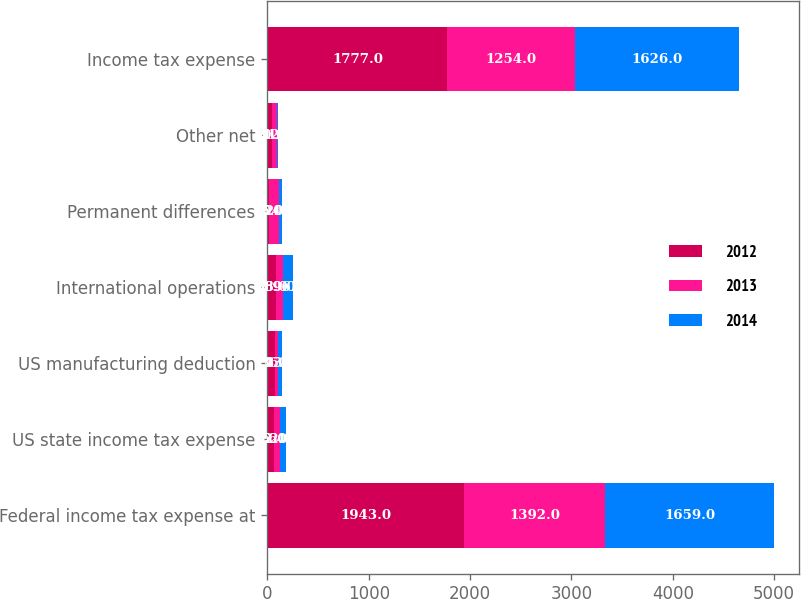Convert chart to OTSL. <chart><loc_0><loc_0><loc_500><loc_500><stacked_bar_chart><ecel><fcel>Federal income tax expense at<fcel>US state income tax expense<fcel>US manufacturing deduction<fcel>International operations<fcel>Permanent differences<fcel>Other net<fcel>Income tax expense<nl><fcel>2012<fcel>1943<fcel>62<fcel>74<fcel>88<fcel>16<fcel>50<fcel>1777<nl><fcel>2013<fcel>1392<fcel>62<fcel>36<fcel>69<fcel>104<fcel>41<fcel>1254<nl><fcel>2014<fcel>1659<fcel>64<fcel>33<fcel>96<fcel>20<fcel>12<fcel>1626<nl></chart> 